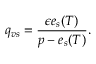Convert formula to latex. <formula><loc_0><loc_0><loc_500><loc_500>q _ { v s } = \frac { \epsilon e _ { s } ( T ) } { p - e _ { s } ( T ) } .</formula> 